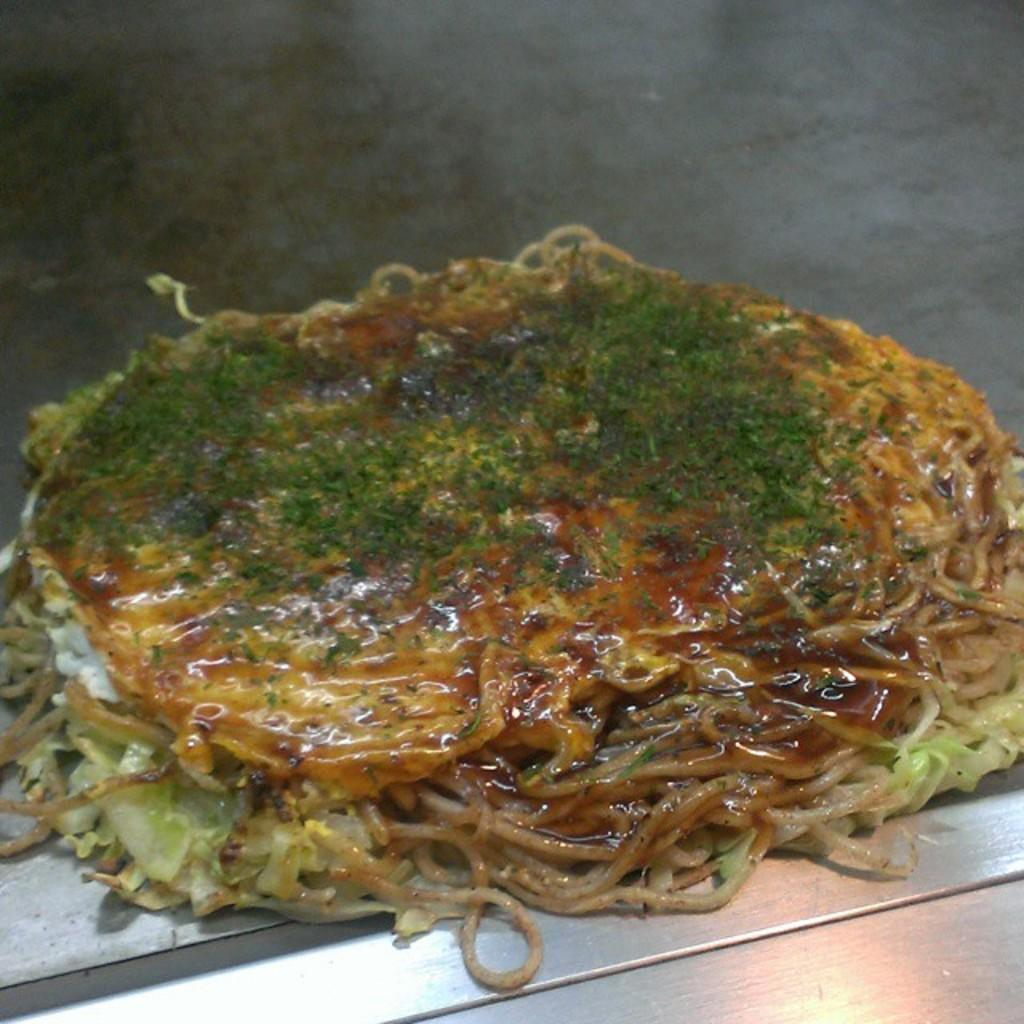What type of food is visible in the image? There are noodles in the image. What is the color of the other object in the image? There is a green color thing in the image. What type of bag is visible in the image? There is no bag present in the image. How does the green color thing care for the noodles in the image? The green color thing does not care for the noodles in the image; it is a separate object. 